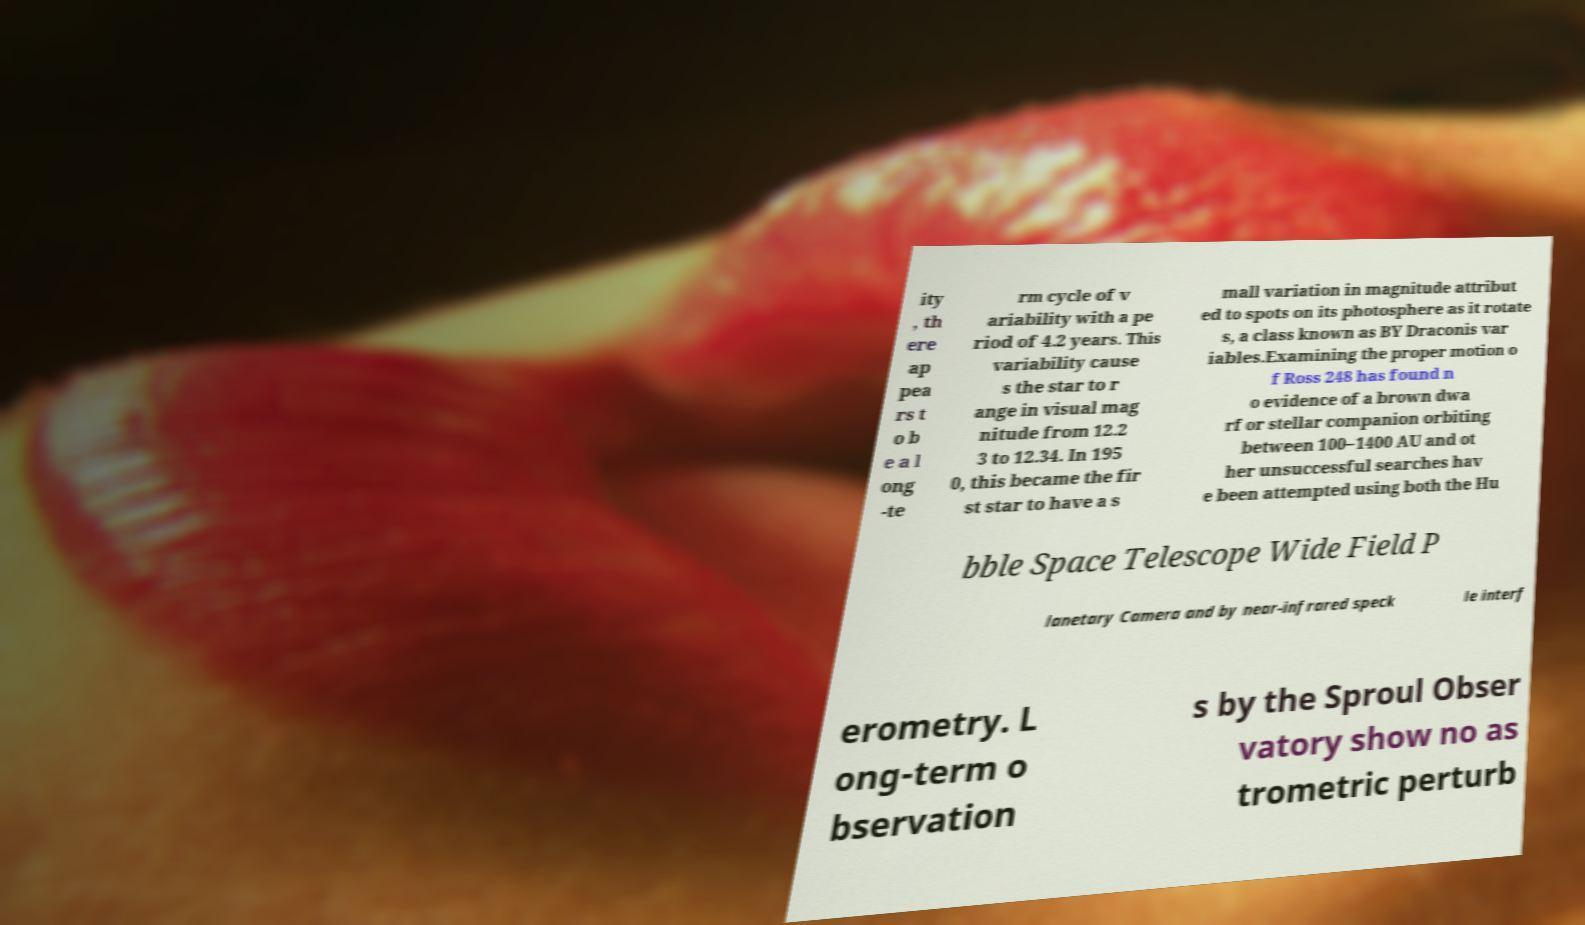Could you extract and type out the text from this image? ity , th ere ap pea rs t o b e a l ong -te rm cycle of v ariability with a pe riod of 4.2 years. This variability cause s the star to r ange in visual mag nitude from 12.2 3 to 12.34. In 195 0, this became the fir st star to have a s mall variation in magnitude attribut ed to spots on its photosphere as it rotate s, a class known as BY Draconis var iables.Examining the proper motion o f Ross 248 has found n o evidence of a brown dwa rf or stellar companion orbiting between 100–1400 AU and ot her unsuccessful searches hav e been attempted using both the Hu bble Space Telescope Wide Field P lanetary Camera and by near-infrared speck le interf erometry. L ong-term o bservation s by the Sproul Obser vatory show no as trometric perturb 